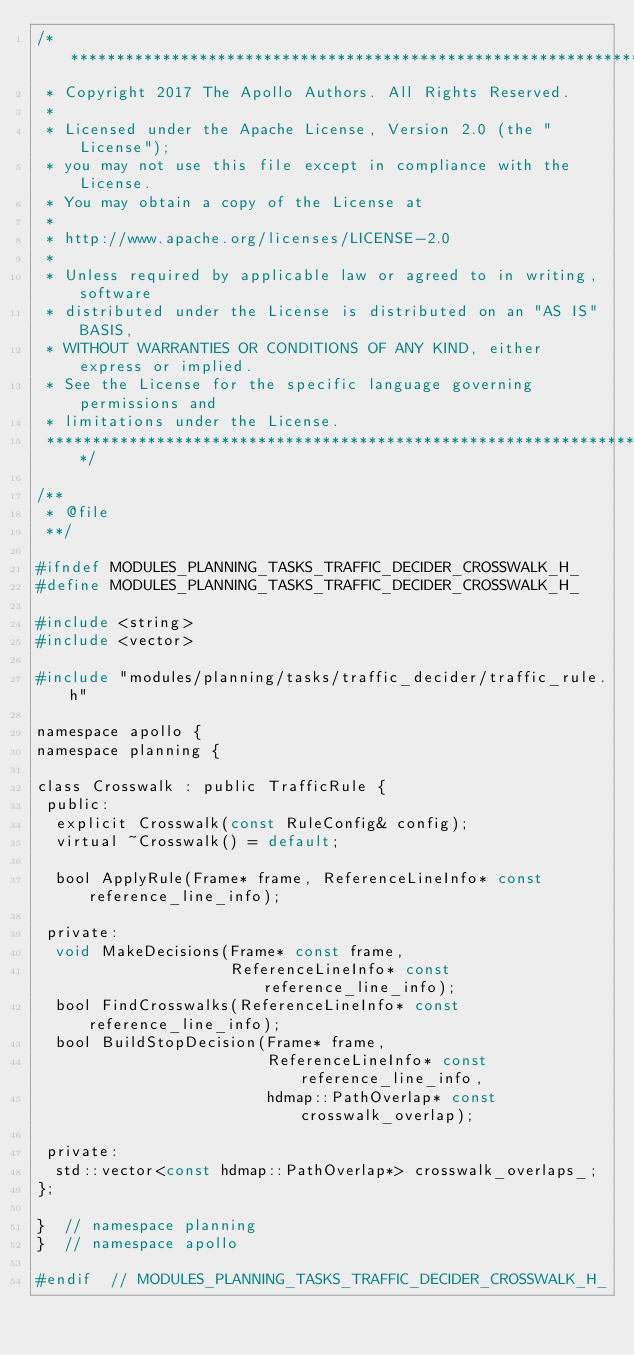<code> <loc_0><loc_0><loc_500><loc_500><_C_>/******************************************************************************
 * Copyright 2017 The Apollo Authors. All Rights Reserved.
 *
 * Licensed under the Apache License, Version 2.0 (the "License");
 * you may not use this file except in compliance with the License.
 * You may obtain a copy of the License at
 *
 * http://www.apache.org/licenses/LICENSE-2.0
 *
 * Unless required by applicable law or agreed to in writing, software
 * distributed under the License is distributed on an "AS IS" BASIS,
 * WITHOUT WARRANTIES OR CONDITIONS OF ANY KIND, either express or implied.
 * See the License for the specific language governing permissions and
 * limitations under the License.
 *****************************************************************************/

/**
 * @file
 **/

#ifndef MODULES_PLANNING_TASKS_TRAFFIC_DECIDER_CROSSWALK_H_
#define MODULES_PLANNING_TASKS_TRAFFIC_DECIDER_CROSSWALK_H_

#include <string>
#include <vector>

#include "modules/planning/tasks/traffic_decider/traffic_rule.h"

namespace apollo {
namespace planning {

class Crosswalk : public TrafficRule {
 public:
  explicit Crosswalk(const RuleConfig& config);
  virtual ~Crosswalk() = default;

  bool ApplyRule(Frame* frame, ReferenceLineInfo* const reference_line_info);

 private:
  void MakeDecisions(Frame* const frame,
                     ReferenceLineInfo* const reference_line_info);
  bool FindCrosswalks(ReferenceLineInfo* const reference_line_info);
  bool BuildStopDecision(Frame* frame,
                         ReferenceLineInfo* const reference_line_info,
                         hdmap::PathOverlap* const crosswalk_overlap);

 private:
  std::vector<const hdmap::PathOverlap*> crosswalk_overlaps_;
};

}  // namespace planning
}  // namespace apollo

#endif  // MODULES_PLANNING_TASKS_TRAFFIC_DECIDER_CROSSWALK_H_
</code> 